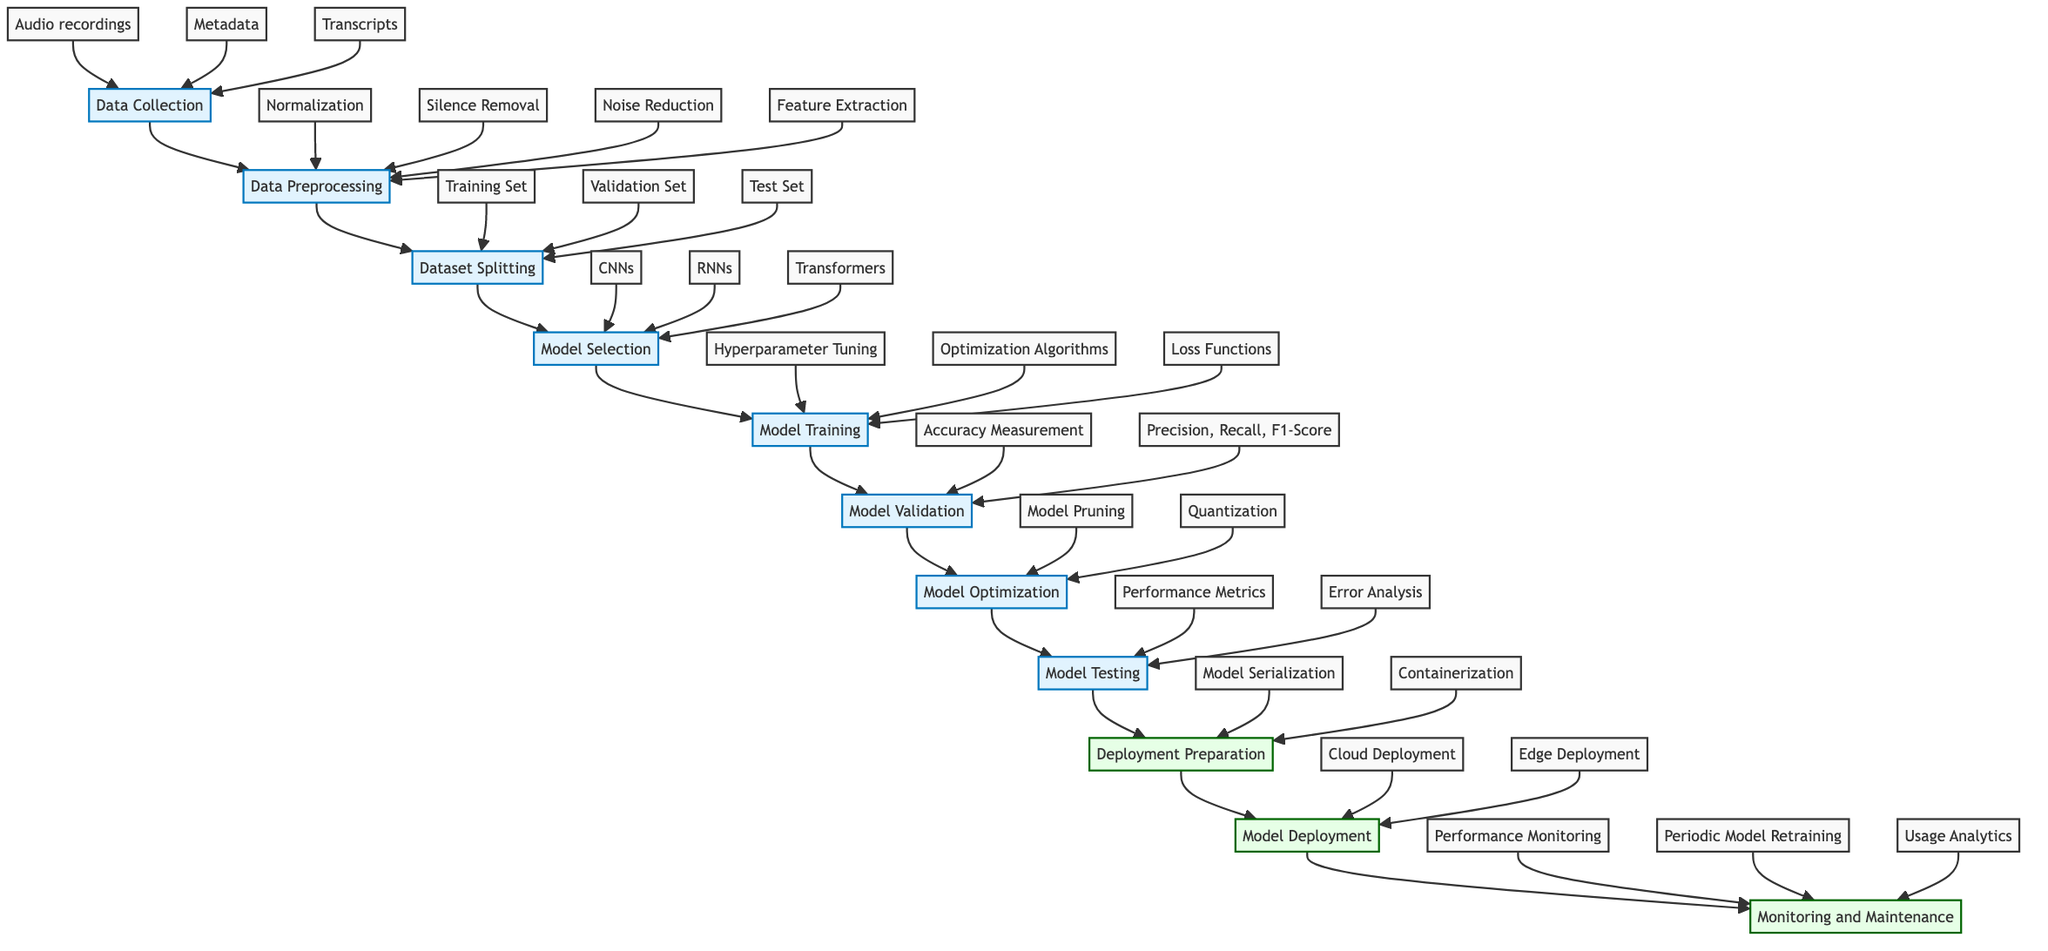What is the first step in the workflow? The first step in the workflow is labeled "Data Collection," which initiates the process for training and testing audio transcription algorithms.
Answer: Data Collection How many main process steps are displayed in the diagram? The diagram displays ten main process steps from "Data Collection" to "Monitoring and Maintenance," allowing a clear view of the overall workflow.
Answer: Ten What models are considered in the Model Selection phase? In the Model Selection phase, three types of model architectures are mentioned: Convolutional Neural Networks, Recurrent Neural Networks, and Transformers.
Answer: CNNs, RNNs, Transformers Which process follows Model Training? Following Model Training, the next process in the workflow is Model Validation, where the performance of the model is evaluated on the validation set.
Answer: Model Validation What is the final stage of the workflow? The final stage of the workflow is "Monitoring and Maintenance," highlighting the ongoing need to observe and update deployed models.
Answer: Monitoring and Maintenance What is one method listed under Model Optimization? One specific method listed under Model Optimization is "Model Pruning," which refers to reducing the size of a model while maintaining performance.
Answer: Model Pruning How are models prepared for deployment? Models are prepared for deployment through "Model Serialization" and "Containerization," which involve saving the model's architecture and packaging it for execution.
Answer: Model Serialization, Containerization What type of deployment is indicated under Model Deployment? The types of deployment indicated under Model Deployment include "Cloud Deployment" and "Edge Deployment," each serving different application needs.
Answer: Cloud Deployment, Edge Deployment What is indicated as an outcome of Model Testing? An outcome of Model Testing is "Performance Metrics," which refers to quantitative measures used to evaluate model effectiveness.
Answer: Performance Metrics What is a sub-element of Data Preprocessing? A sub-element of Data Preprocessing includes "Feature Extraction," which involves deriving relevant features from the audio data for model training.
Answer: Feature Extraction 